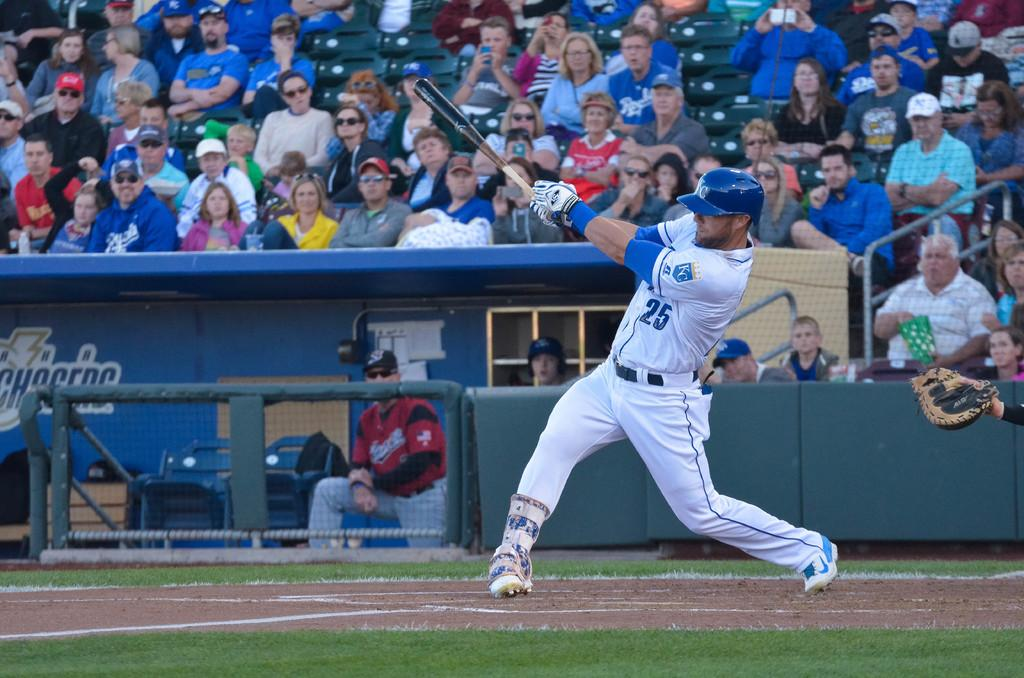Provide a one-sentence caption for the provided image. A baseball player that is wearing the number 25 on his jersey swings a bat. 